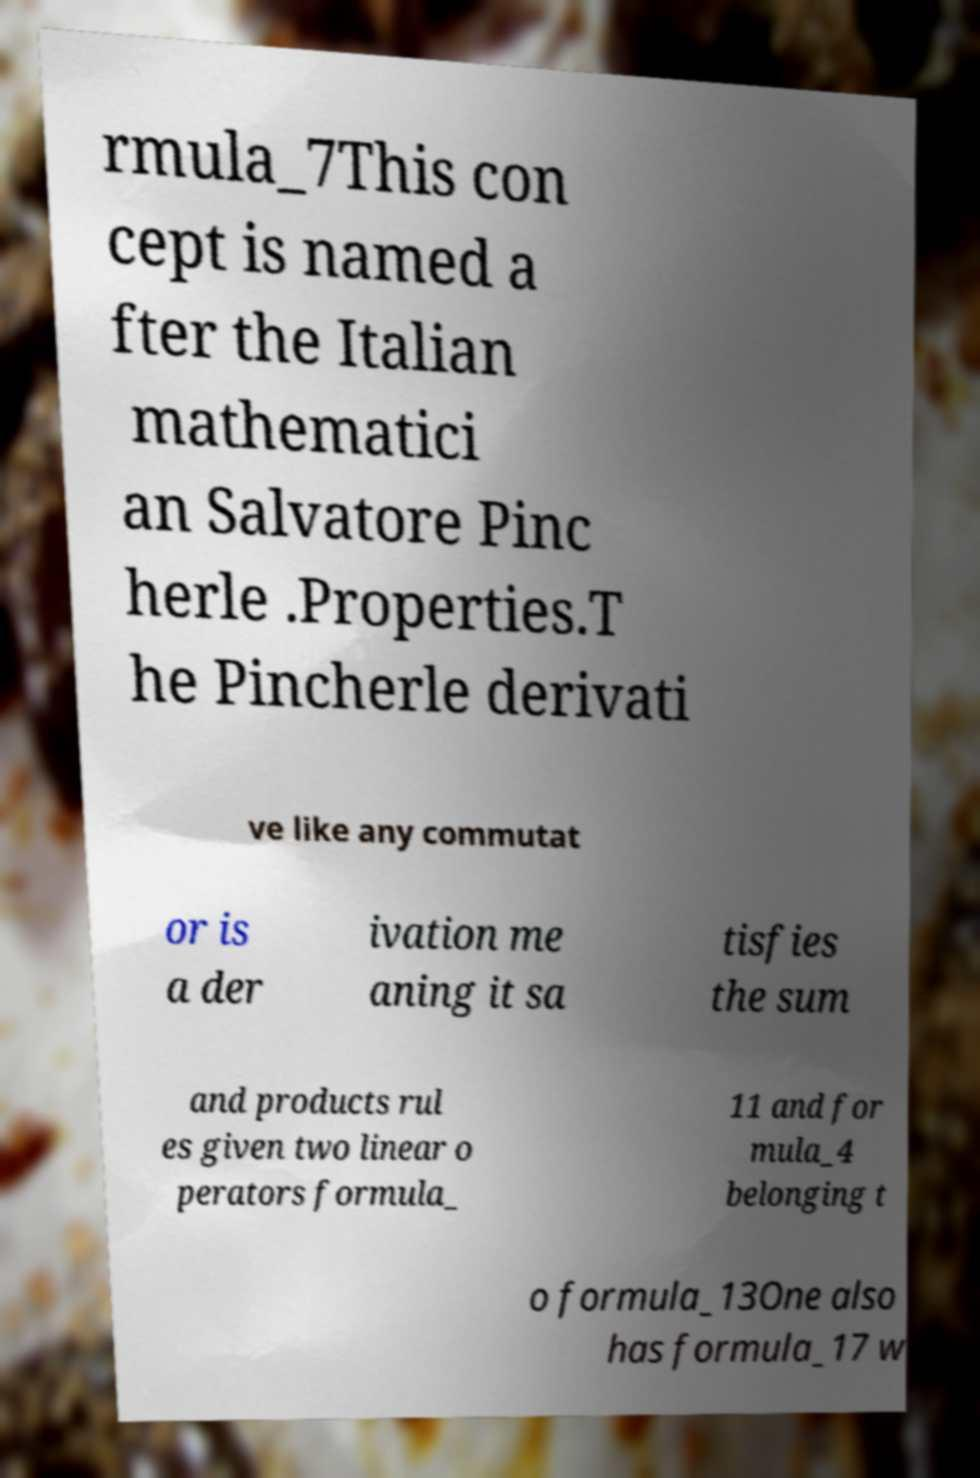Please read and relay the text visible in this image. What does it say? rmula_7This con cept is named a fter the Italian mathematici an Salvatore Pinc herle .Properties.T he Pincherle derivati ve like any commutat or is a der ivation me aning it sa tisfies the sum and products rul es given two linear o perators formula_ 11 and for mula_4 belonging t o formula_13One also has formula_17 w 